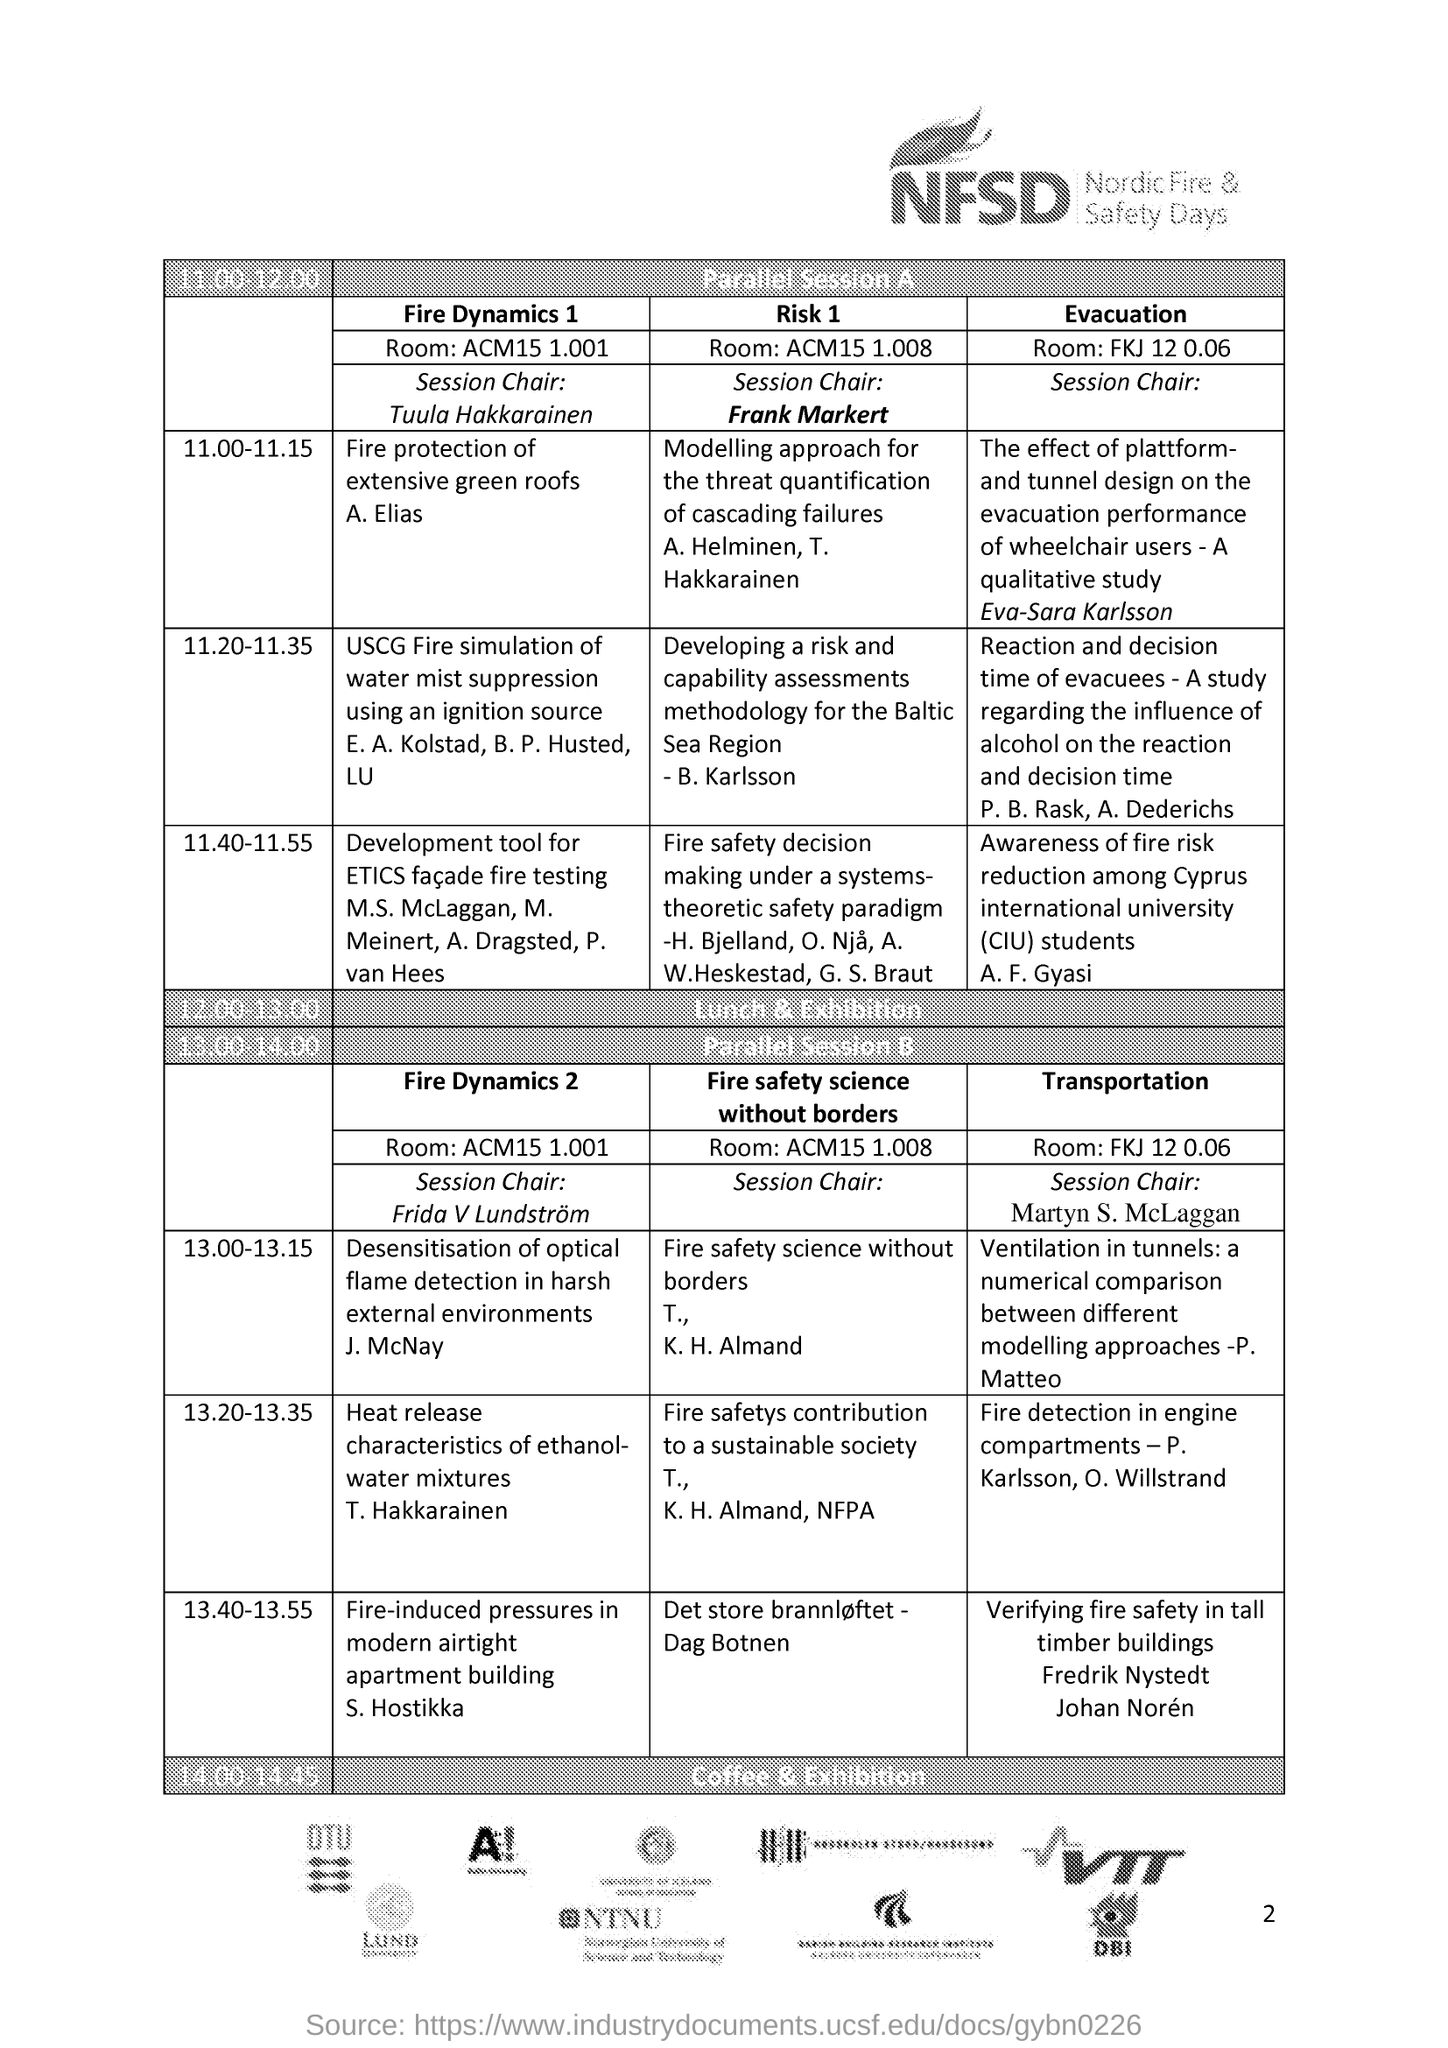What is the fullform of NFSD?
Your answer should be compact. Nordic Fire & Safety Days. Who is the session chair for 'Fire Dynamics 1'?
Make the answer very short. Tuula Hakkarainen. Who is the session chair for 'Fire Dynamics 2'?
Give a very brief answer. Frida V Lundstrom. Who is presenting the session on 'Heat release characteristics of ethanol-water mixtures'?
Your answer should be very brief. T. Hakkarainen. Who is presenting the session on 'Fire protection of extensive green roofs'?
Your answer should be very brief. A. Elias. Who is the session chair for 'Risk 1'?
Your answer should be compact. Frank Markert. Which session is carried out by S. Hostikka in parallel session B?
Your response must be concise. Fire-induced pressures in modern airtight apartment building. What time is the parallel session A carried out?
Your answer should be compact. 11:00-12:00. 